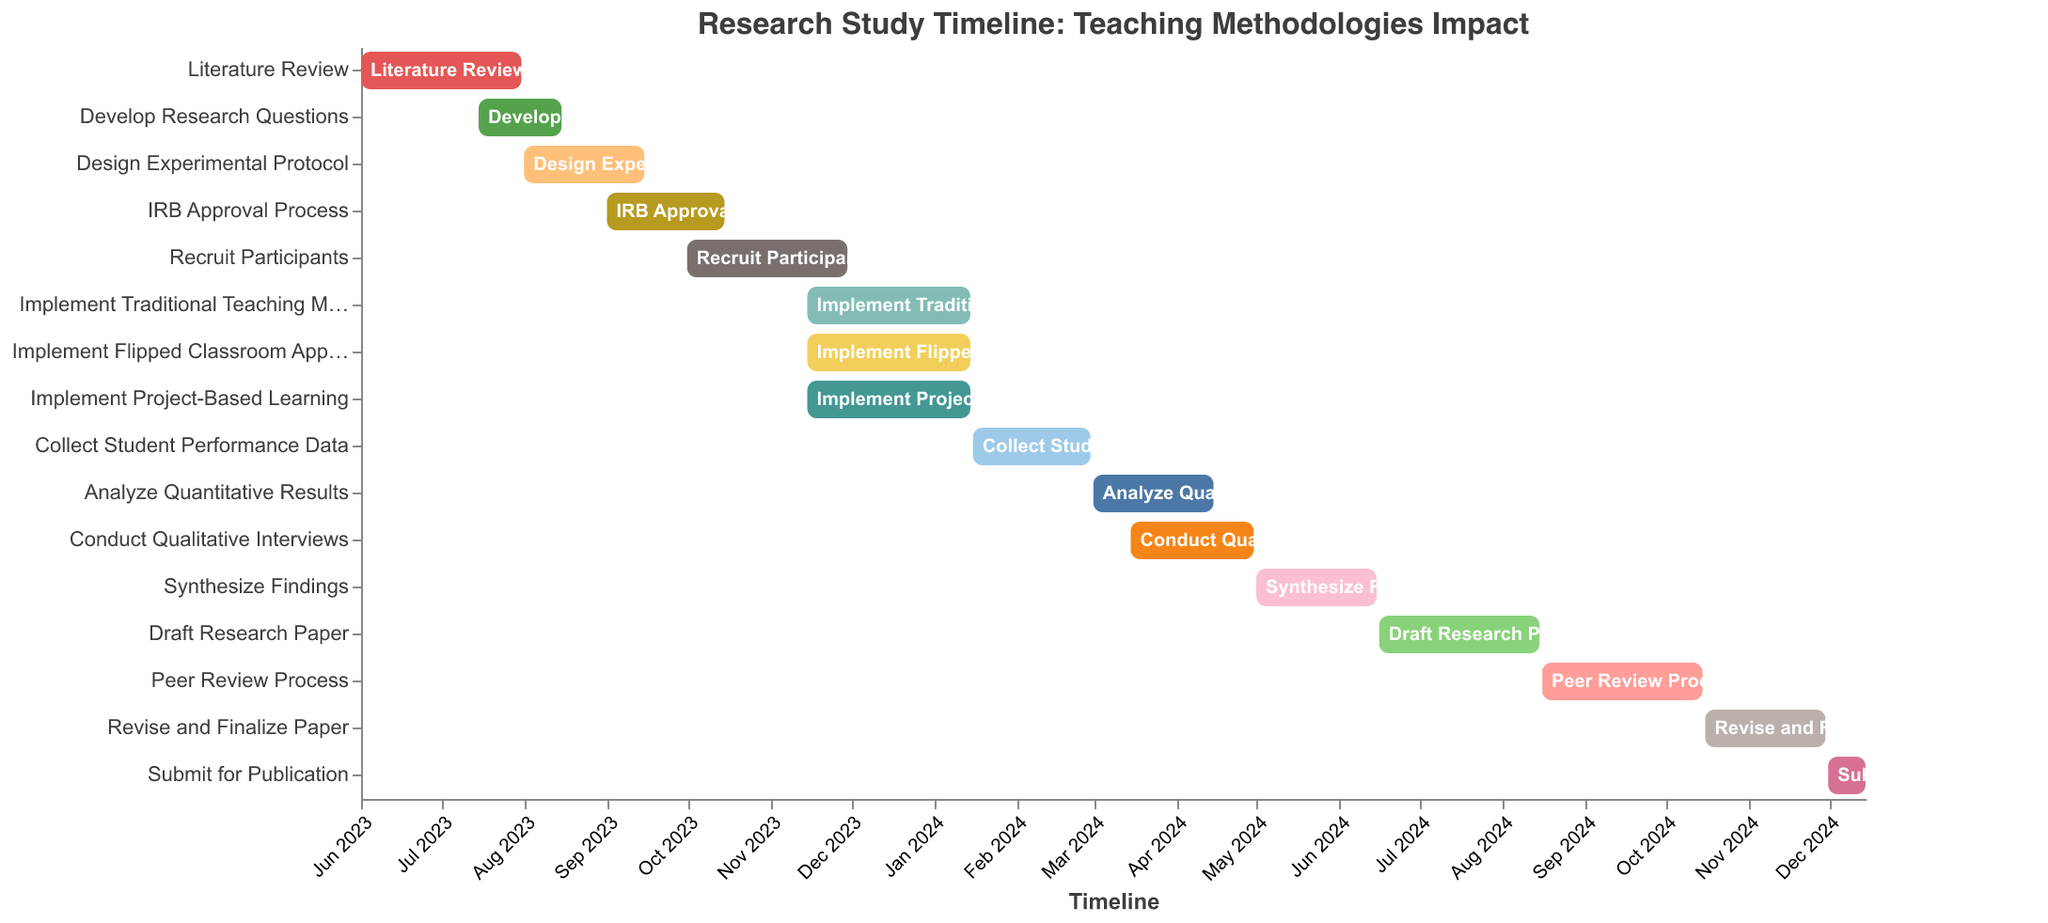When does the Literature Review start and end? According to the visual information in the figure, the Literature Review starts on June 1, 2023, and ends on July 31, 2023.
Answer: June 1, 2023, to July 31, 2023 What is the duration of the IRB Approval Process? The IRB Approval Process starts on September 1, 2023, and ends on October 15, 2023. The duration can be calculated by counting the days from September 1 to October 15.
Answer: 45 days Which task immediately follows the Data Collection phase? The Data Collection phase is labeled "Collect Student Performance Data" and ends on February 29, 2024. The next task that starts after this period is "Analyze Quantitative Results" on March 1, 2024.
Answer: Analyze Quantitative Results How many tasks are implemented during the data collection phase? The data collection phase, "Collect Student Performance Data," runs from January 16, 2024, to February 29, 2024. During this phase, no other tasks start or end. Hence there is only one task during this phase.
Answer: 1 Which task has the longest duration? By comparing the start and end dates for each task, "Implement Traditional Teaching Method," "Implement Flipped Classroom Approach," and "Implement Project-Based Learning" all run from November 15, 2023, to January 15, 2024, making them the longest tasks with a duration of 61 days each.
Answer: Implement Traditional Teaching Method, Implement Flipped Classroom Approach, Implement Project-Based Learning What are the three methodologies implemented simultaneously? According to the figure, "Implement Traditional Teaching Method," "Implement Flipped Classroom Approach," and "Implement Project-Based Learning" all start on November 15, 2023, and end on January 15, 2024.
Answer: Implement Traditional Teaching Method, Implement Flipped Classroom Approach, Implement Project-Based Learning For how long does the Peer Review Process last? Observing the timelines, the Peer Review Process starts on August 16, 2024, and ends on October 15, 2024. Calculating the days between these dates, the duration is 61 days.
Answer: 61 days What is the final task in the research timeline? The final task shown in the figure is "Submit for Publication," which starts on December 1, 2024, and ends on December 15, 2024.
Answer: Submit for Publication 